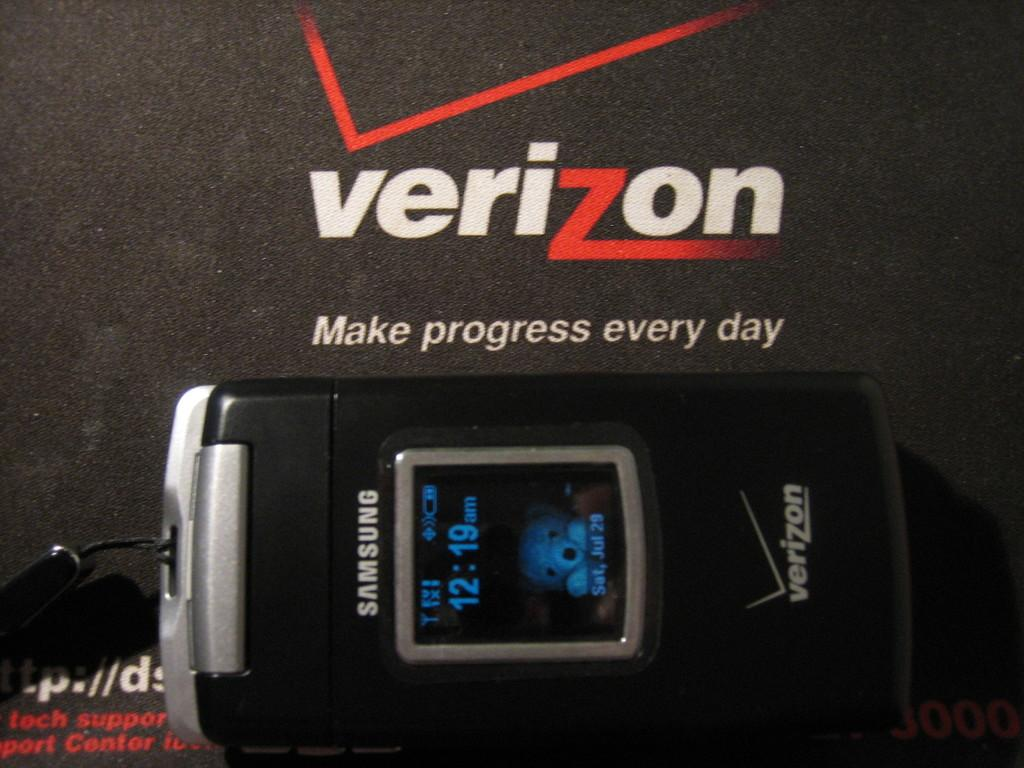<image>
Create a compact narrative representing the image presented. A samsung flip phone and a verizon advertisement. 